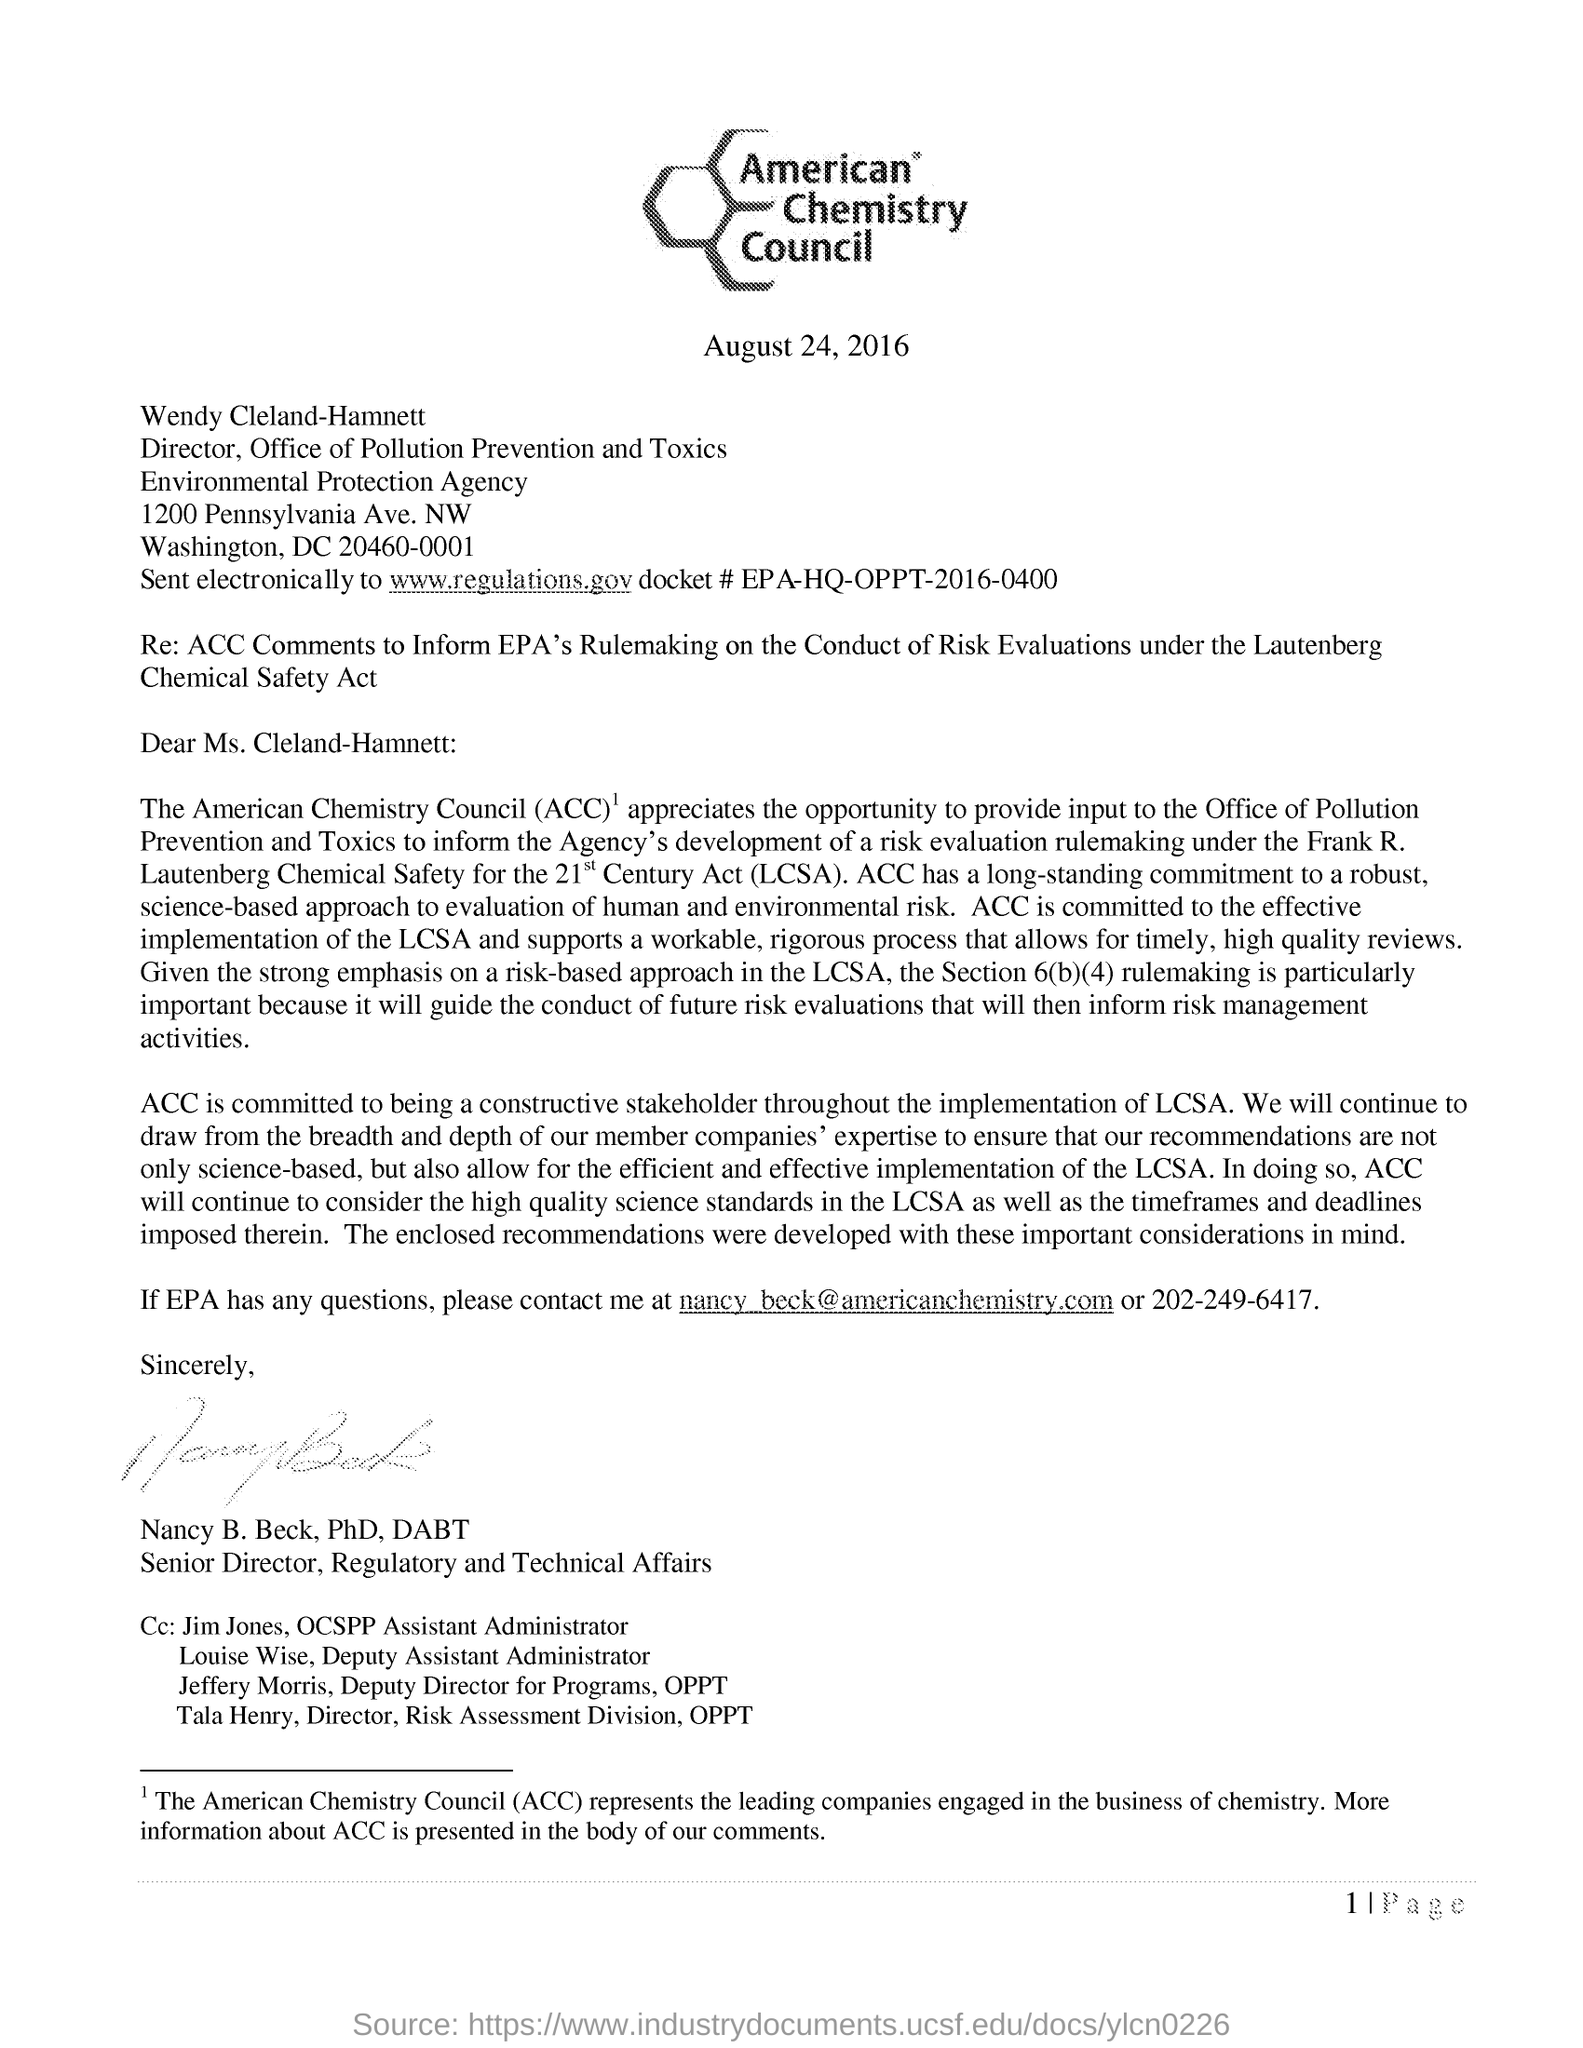What is the fullform of ACC?
Make the answer very short. American Chemistry Council. What does ACC represents?
Keep it short and to the point. Leading companies engaged in the business of chemistry. Who is the director of office of Pollution Prevention and Toxics?
Keep it short and to the point. Wendy Cleland-Hamnett. Who is the sender of this letter?
Provide a short and direct response. Nancy B. Beck, PhD, DABT. What is the date mentioned in this letter?
Your response must be concise. August 24, 2016. 